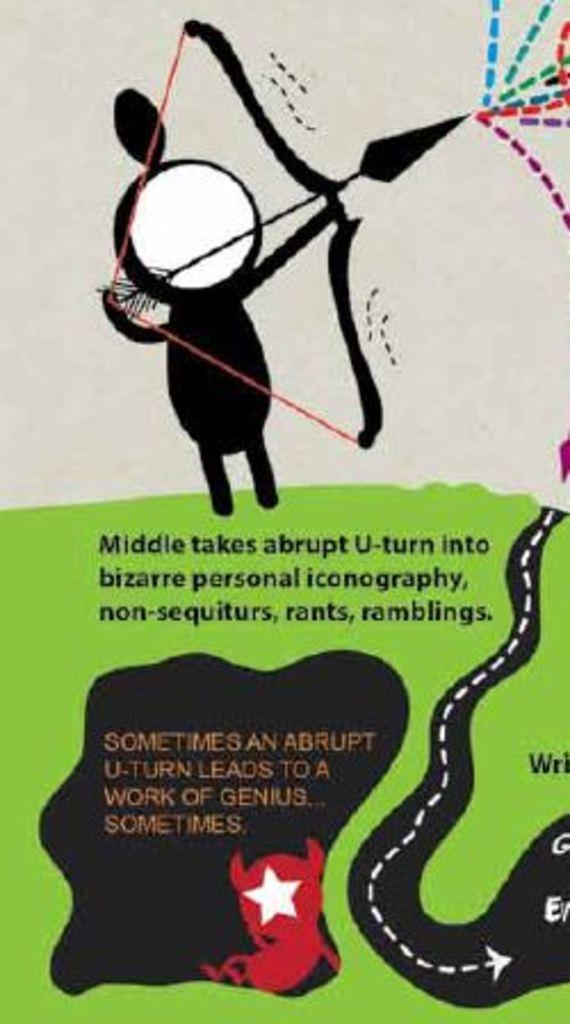What is present on the poster in the image? There is a poster in the image. What type of images are featured on the poster? The poster contains cartoon pictures. What else is present on the poster besides the images? The poster contains text. What type of war is depicted in the cartoon pictures on the poster? There is no war depicted in the cartoon pictures on the poster; the images are not related to any conflict or battle. 